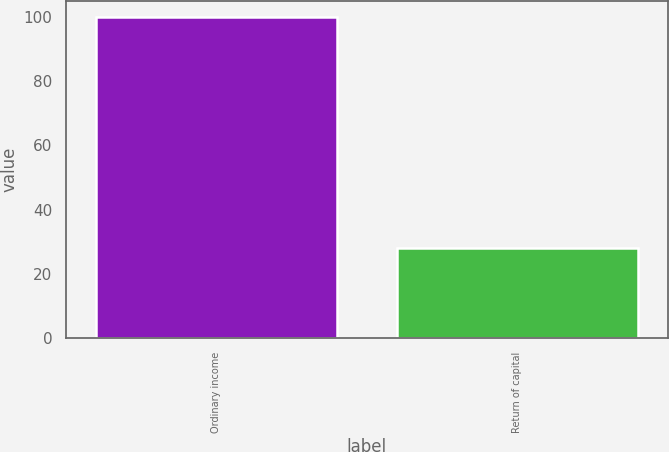Convert chart. <chart><loc_0><loc_0><loc_500><loc_500><bar_chart><fcel>Ordinary income<fcel>Return of capital<nl><fcel>100<fcel>28<nl></chart> 